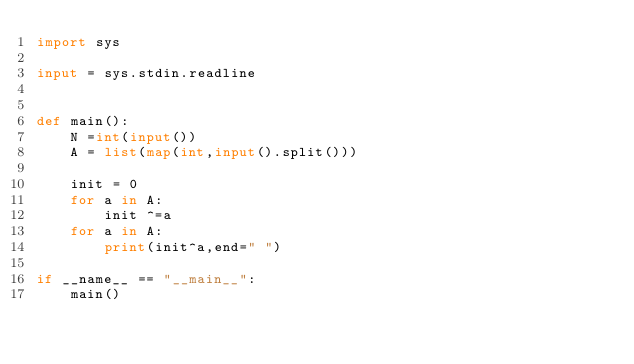Convert code to text. <code><loc_0><loc_0><loc_500><loc_500><_Python_>import sys

input = sys.stdin.readline


def main():
    N =int(input())
    A = list(map(int,input().split()))

    init = 0
    for a in A:
        init ^=a
    for a in A:
        print(init^a,end=" ")

if __name__ == "__main__":
    main()</code> 